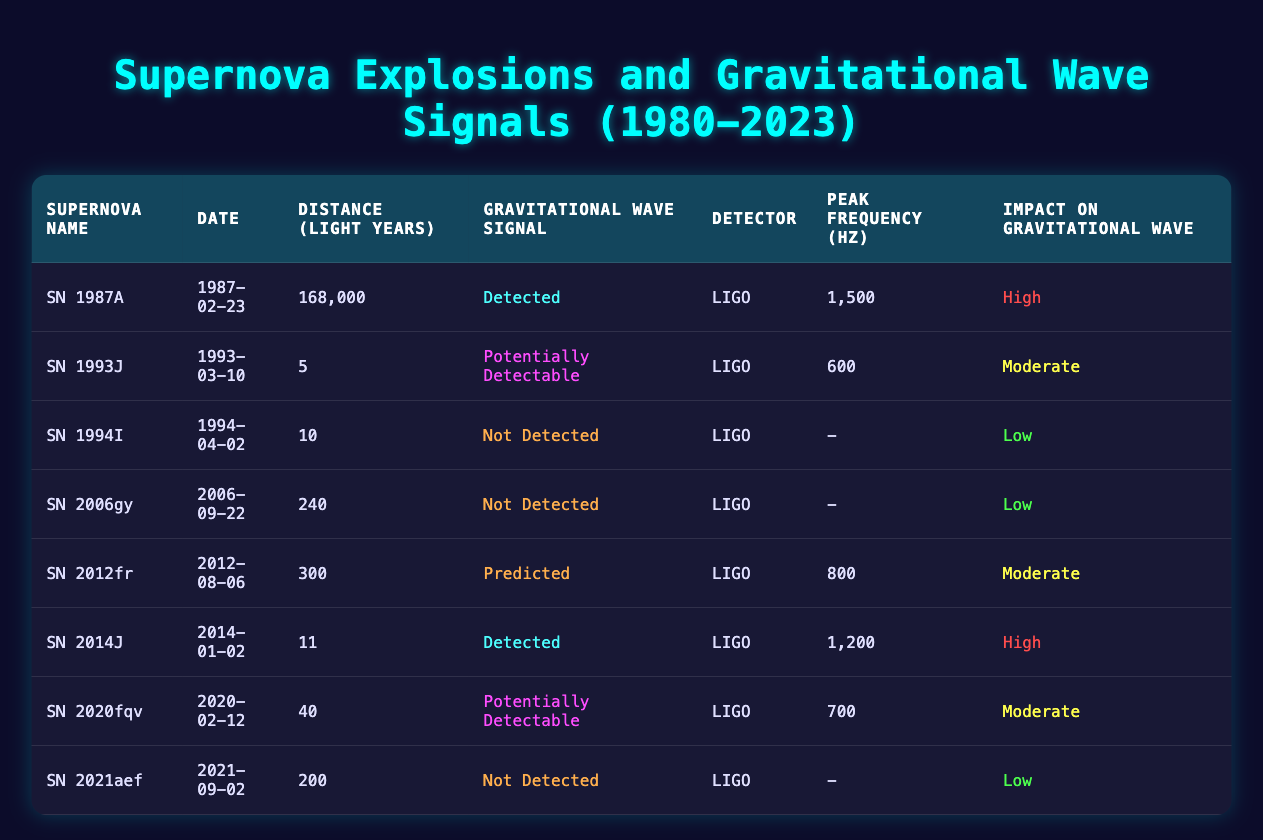What was the closest supernova explosion recorded in the table? The table shows the distance in light years for each supernova. The one with the smallest distance is SN 1993J, which is 5 light years away.
Answer: SN 1993J Which supernova explosion resulted in a "not detected" gravitational wave signal? By examining the "Gravitational Wave Signal" column, I can find that SN 1994I, SN 2006gy, and SN 2021aef all have "Not Detected" listed.
Answer: SN 1994I, SN 2006gy, SN 2021aef What is the peak frequency of the supernova explosion with the highest impact on gravitational waves? I look for the supernova with "High" as its impact and check its peak frequency. SN 1987A and SN 2014J both have high impact. SN 1987A has a peak frequency of 1500 Hz, and SN 2014J has 1200 Hz. Thus, the highest is 1500 Hz from SN 1987A.
Answer: 1500 Hz Is it true that all supernova events detected in the table had a high impact on gravitational wave signals? I need to examine the "Impact on Gravitational Wave" column for all rows where the "Gravitational Wave Signal" is "Detected." There are two such cases: SN 1987A and SN 2014J, both with high impact, making the statement true.
Answer: Yes What is the average distance of the supernova explosions that had a "potentially detectable" gravitational wave signal? The supernova explosions with "Potentially Detectable" signals are SN 1993J and SN 2020fqv. Their distances are 5 and 40 light years. To find the average: (5 + 40) / 2 = 22.5 light years.
Answer: 22.5 light years How many supernova explosions occurred after 2012 that were detected? Counting the supernova entries in the table after 2012, I find SN 2014J was detected. So, there is only one verified event.
Answer: 1 Which supernova explosion with a detected gravitational wave signal was the most distant? Evaluate the distances of supernova explosions that have "detected" signals: SN 1987A is at 168,000 light years, and SN 2014J is at 11 light years. Therefore, SN 1987A is the most distant detected supernova.
Answer: SN 1987A What percentage of the total supernova explosions listed had "not detected" gravitational wave signals? To calculate, I note there are 8 total supernovae, and 3 had "not detected". The percentage is (3/8) * 100 = 37.5%.
Answer: 37.5% 